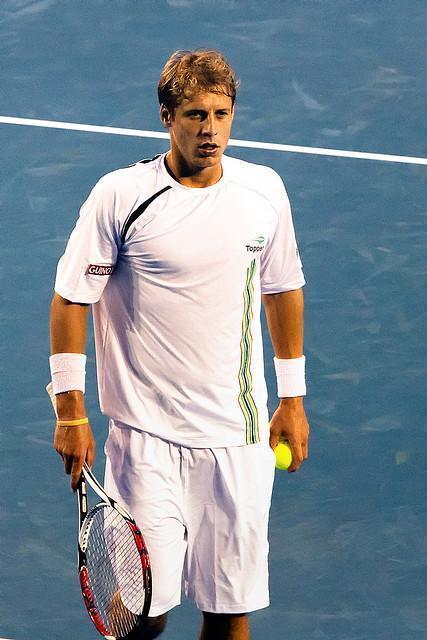Why does he have his forearms wrapped?
Choose the right answer from the provided options to respond to the question.
Options: Is injured, to strengthen, keep on, showing off. To strengthen. 